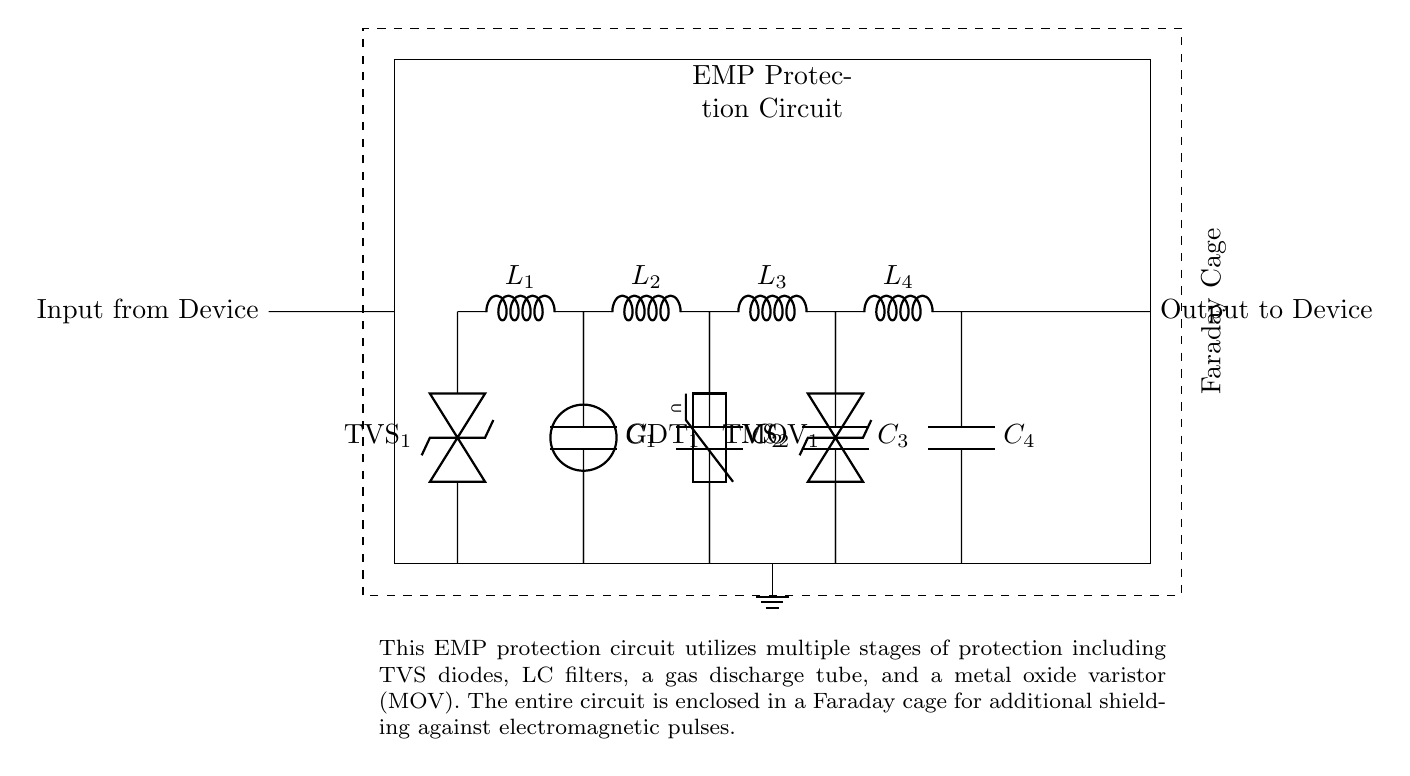What is the main purpose of this circuit? The main purpose of this circuit is to protect mobile devices from electromagnetic pulses by providing multiple layers of protection. This is indicated by the description in the circuit diagram, which mentions EMP protection and the various components used for that purpose.
Answer: EMP protection How many stages of filtering are in this circuit? The circuit contains four stages of filtering as indicated by the four inductors and capacitors labeled L1, C1; L2, C2; L3, C3; and L4, C4. Each pair serves as a filtering stage to protect against EMP.
Answer: Four stages What type of components are used for voltage clamping in this circuit? The circuit uses Transient Voltage Suppression (TVS) diodes and a Metal Oxide Varistor (MOV) for voltage clamping. These components are specifically designed to absorb and divert excessive voltage transients, protecting the mobile device.
Answer: TVS diodes and MOV Which component is responsible for providing additional voltage protection after the gas discharge tube? After the gas discharge tube, the component responsible for additional voltage protection is the Metal Oxide Varistor (MOV). It is connected in series to mitigate voltage surges that might occur even after the gas discharge tube has acted.
Answer: MOV Explain the role of the Faraday cage in this circuit. The Faraday cage serves as a protective barrier that isolates the circuit from external electromagnetic fields, ensuring that electromagnetic pulses do not interfere with the circuit's operation. This is crucial for the integrity of the device being protected. The diagram clearly depicts the Faraday cage around the circuit.
Answer: Electromagnetic shielding What is the function of the gas discharge tube in this circuit? The gas discharge tube functions as a surge protector by ionizing air to create a conductive path when voltage exceeds a certain threshold, effectively clamping voltage and providing an additional layer of protection. This is shown by its position in the circuit after the first LC filter stage.
Answer: Surge protection 